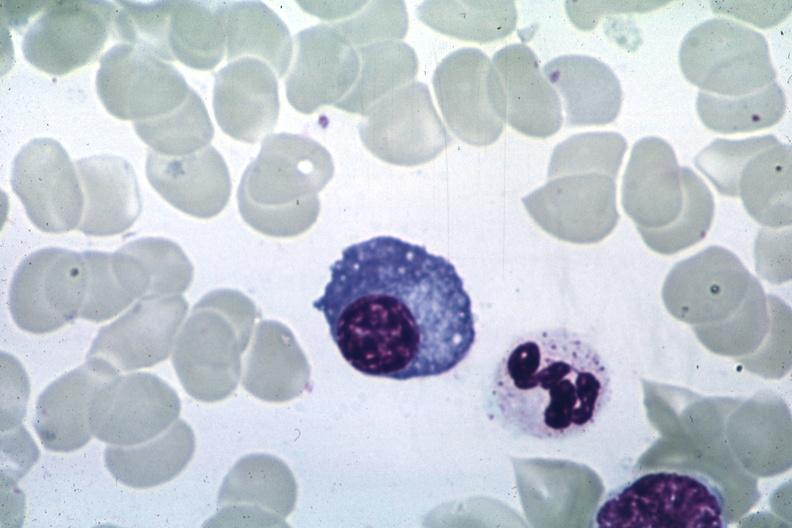what is present?
Answer the question using a single word or phrase. Bone marrow 